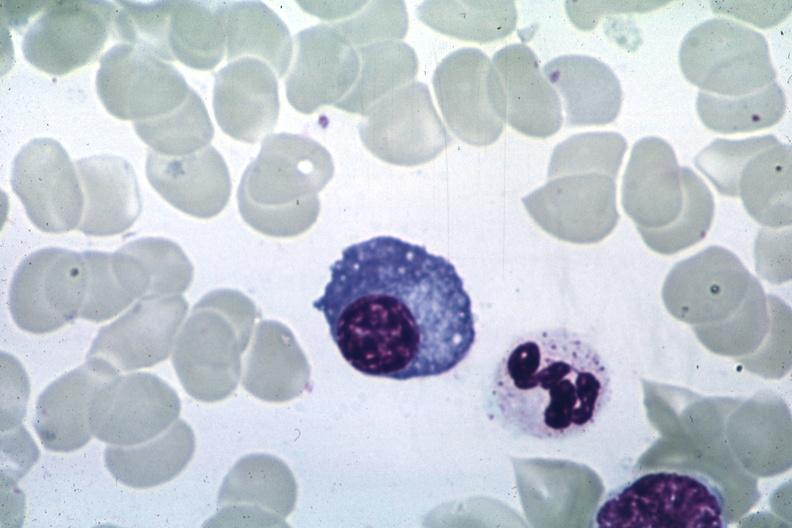what is present?
Answer the question using a single word or phrase. Bone marrow 